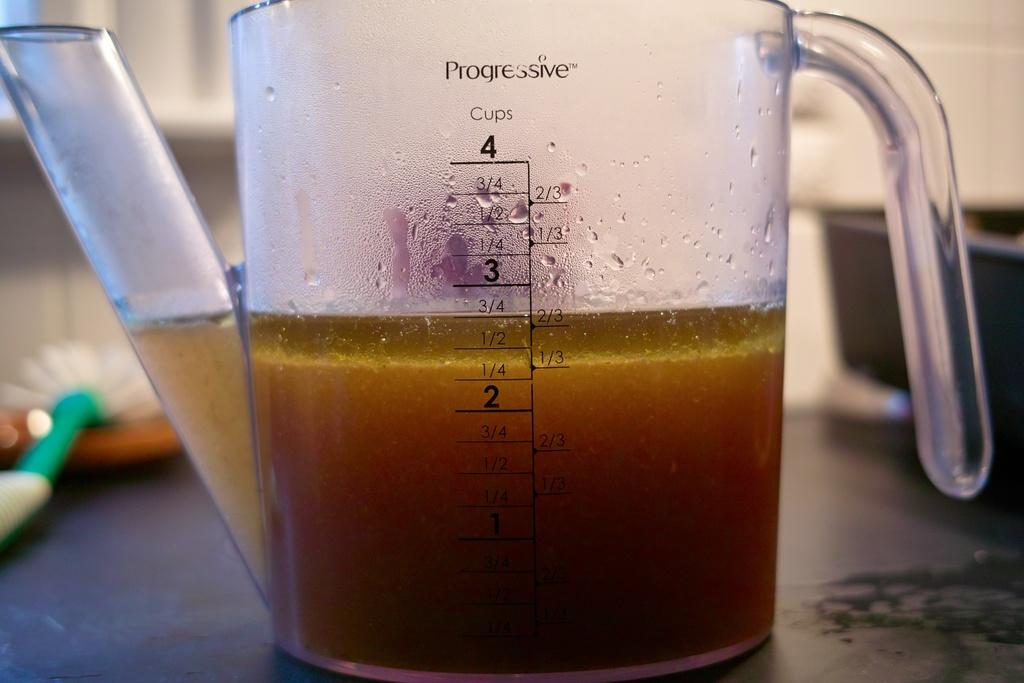<image>
Write a terse but informative summary of the picture. the clear measuring cup will hold four cups of liquid 